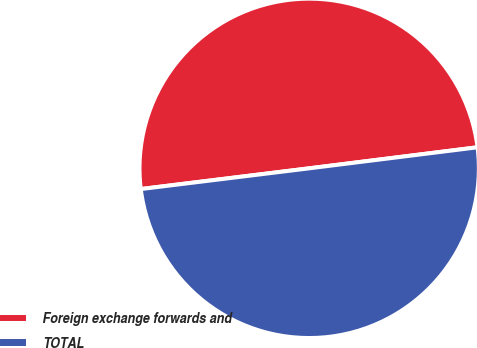Convert chart. <chart><loc_0><loc_0><loc_500><loc_500><pie_chart><fcel>Foreign exchange forwards and<fcel>TOTAL<nl><fcel>49.97%<fcel>50.03%<nl></chart> 